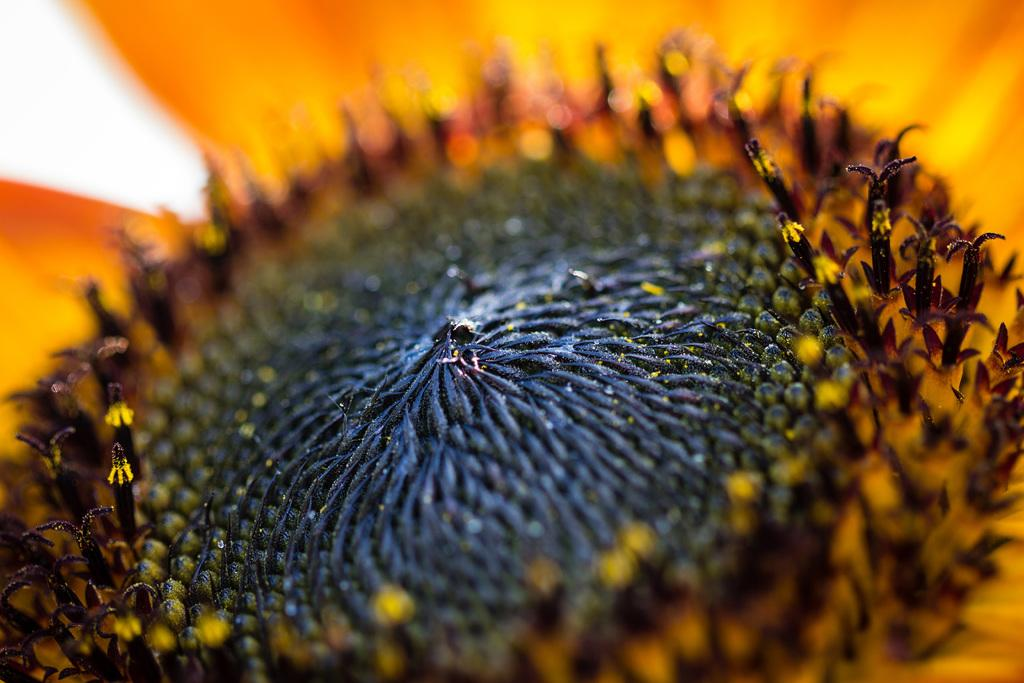What type of plant is in the image? There is a sunflower in the image. Can you describe the background of the image? The background of the image is blurred. How many cents are visible on the sunflower in the image? There are no cents present on the sunflower in the image. What type of chalk is being used to draw on the sunflower in the image? There is no chalk or drawing present on the sunflower in the image. 